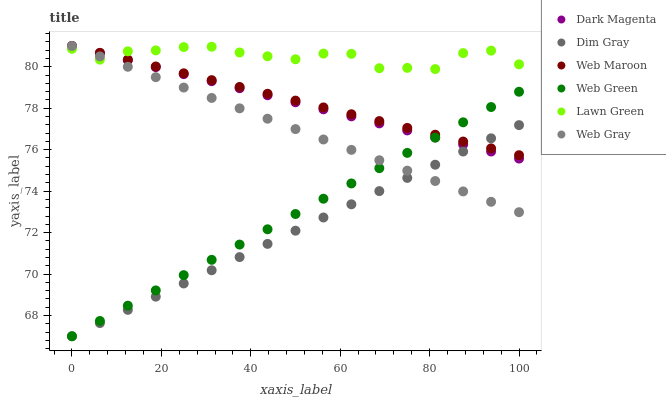Does Dim Gray have the minimum area under the curve?
Answer yes or no. Yes. Does Lawn Green have the maximum area under the curve?
Answer yes or no. Yes. Does Web Gray have the minimum area under the curve?
Answer yes or no. No. Does Web Gray have the maximum area under the curve?
Answer yes or no. No. Is Web Maroon the smoothest?
Answer yes or no. Yes. Is Lawn Green the roughest?
Answer yes or no. Yes. Is Web Gray the smoothest?
Answer yes or no. No. Is Web Gray the roughest?
Answer yes or no. No. Does Web Green have the lowest value?
Answer yes or no. Yes. Does Web Gray have the lowest value?
Answer yes or no. No. Does Web Maroon have the highest value?
Answer yes or no. Yes. Does Web Green have the highest value?
Answer yes or no. No. Is Web Green less than Lawn Green?
Answer yes or no. Yes. Is Lawn Green greater than Web Green?
Answer yes or no. Yes. Does Dark Magenta intersect Dim Gray?
Answer yes or no. Yes. Is Dark Magenta less than Dim Gray?
Answer yes or no. No. Is Dark Magenta greater than Dim Gray?
Answer yes or no. No. Does Web Green intersect Lawn Green?
Answer yes or no. No. 